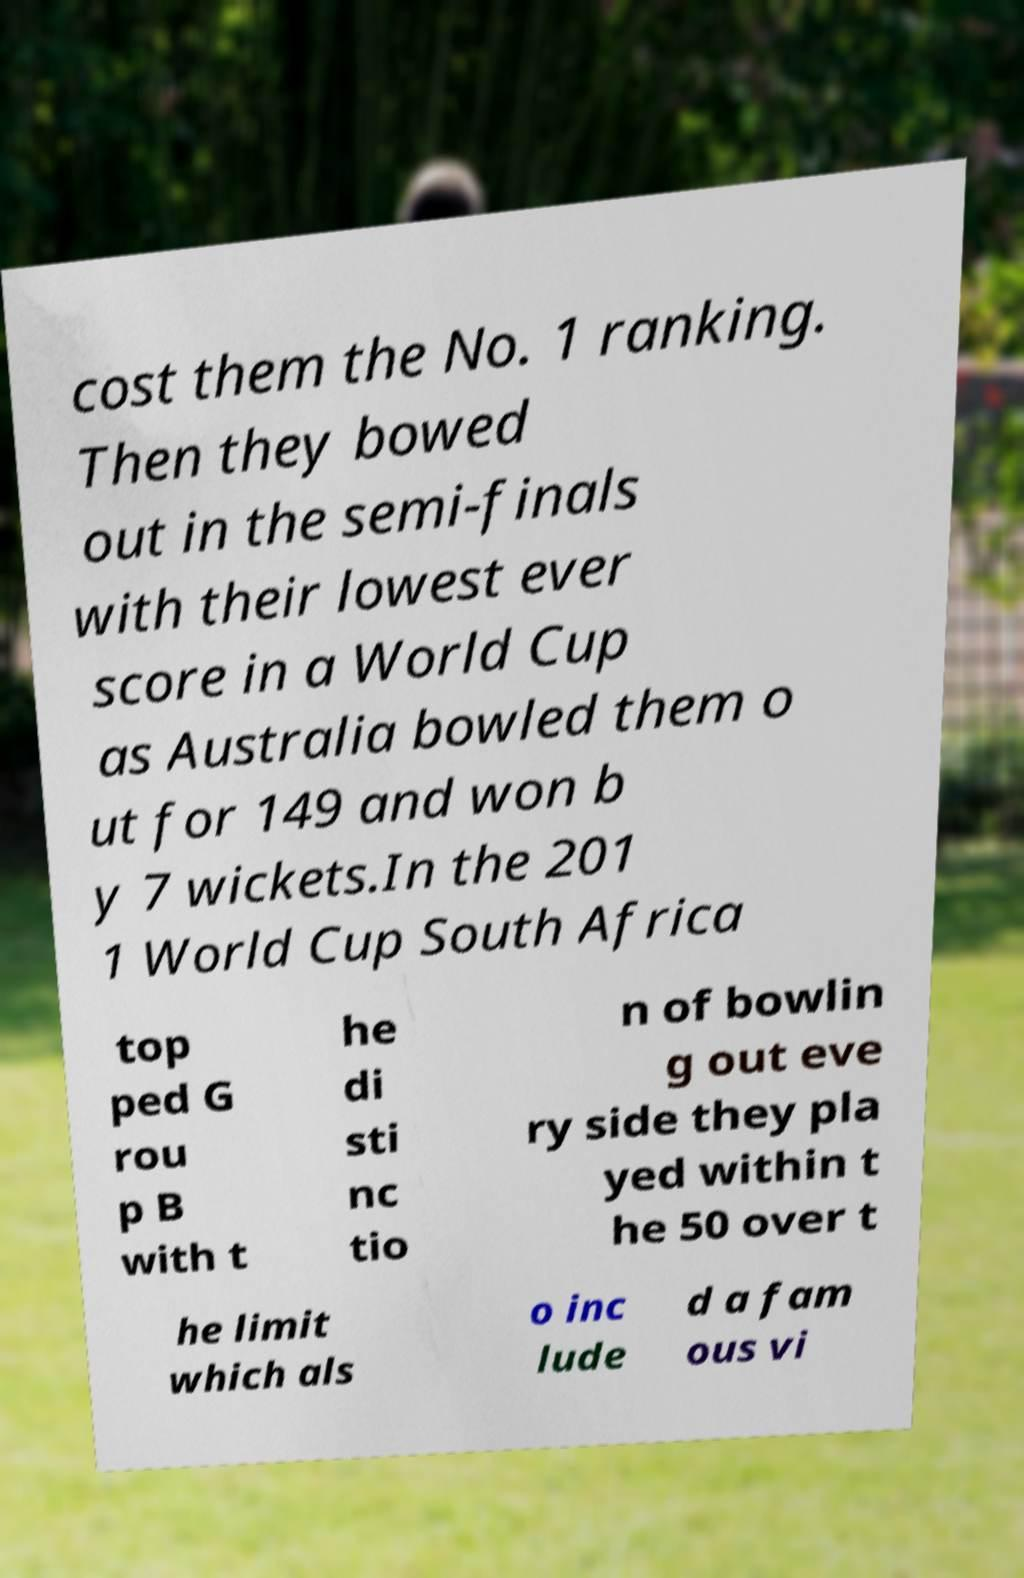I need the written content from this picture converted into text. Can you do that? cost them the No. 1 ranking. Then they bowed out in the semi-finals with their lowest ever score in a World Cup as Australia bowled them o ut for 149 and won b y 7 wickets.In the 201 1 World Cup South Africa top ped G rou p B with t he di sti nc tio n of bowlin g out eve ry side they pla yed within t he 50 over t he limit which als o inc lude d a fam ous vi 